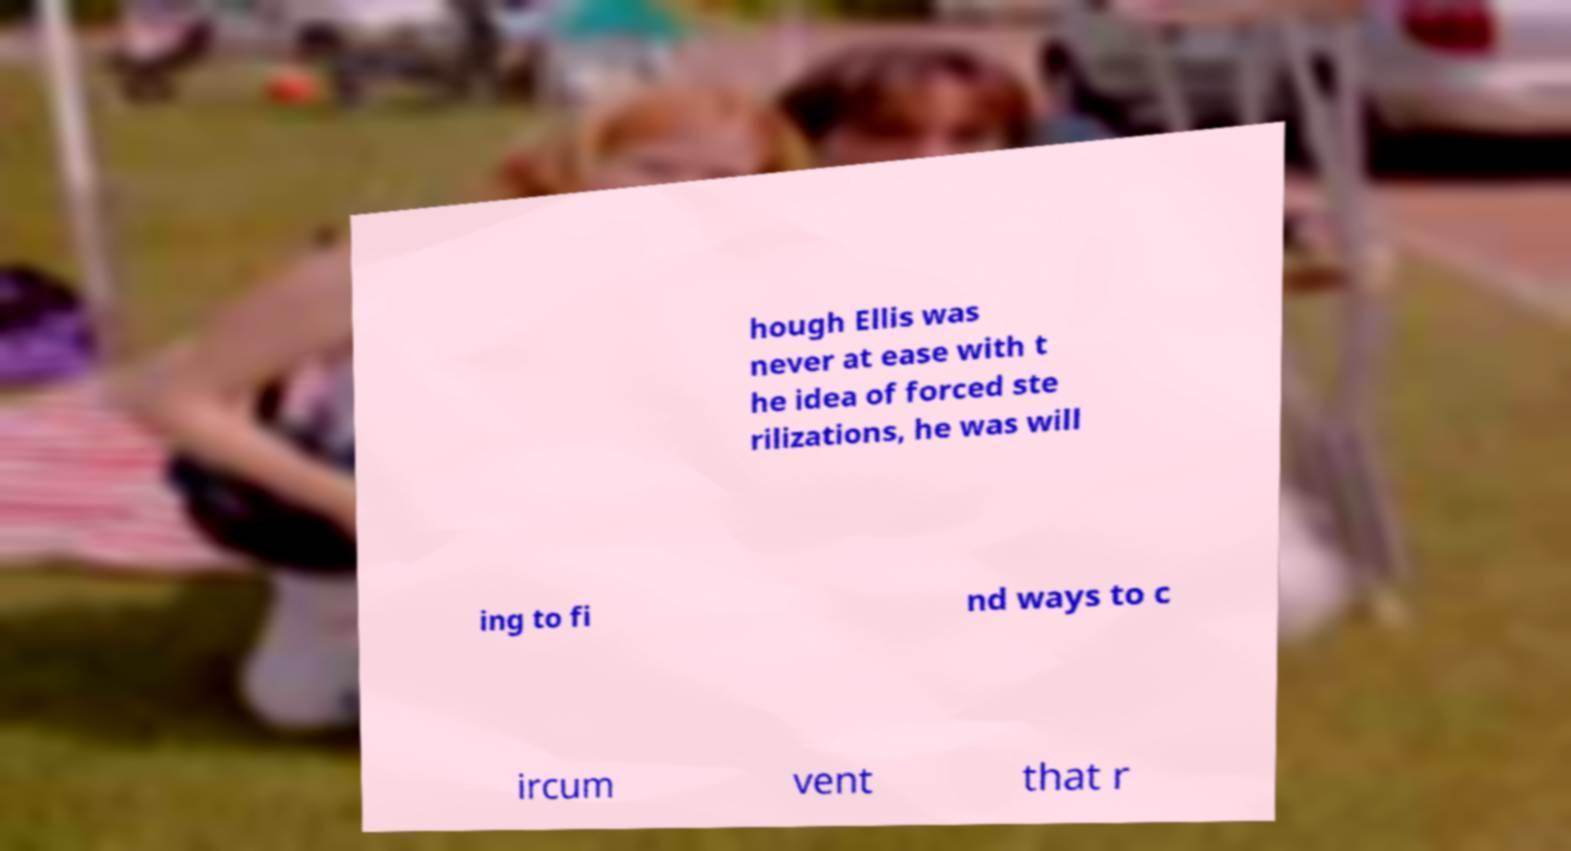What messages or text are displayed in this image? I need them in a readable, typed format. hough Ellis was never at ease with t he idea of forced ste rilizations, he was will ing to fi nd ways to c ircum vent that r 